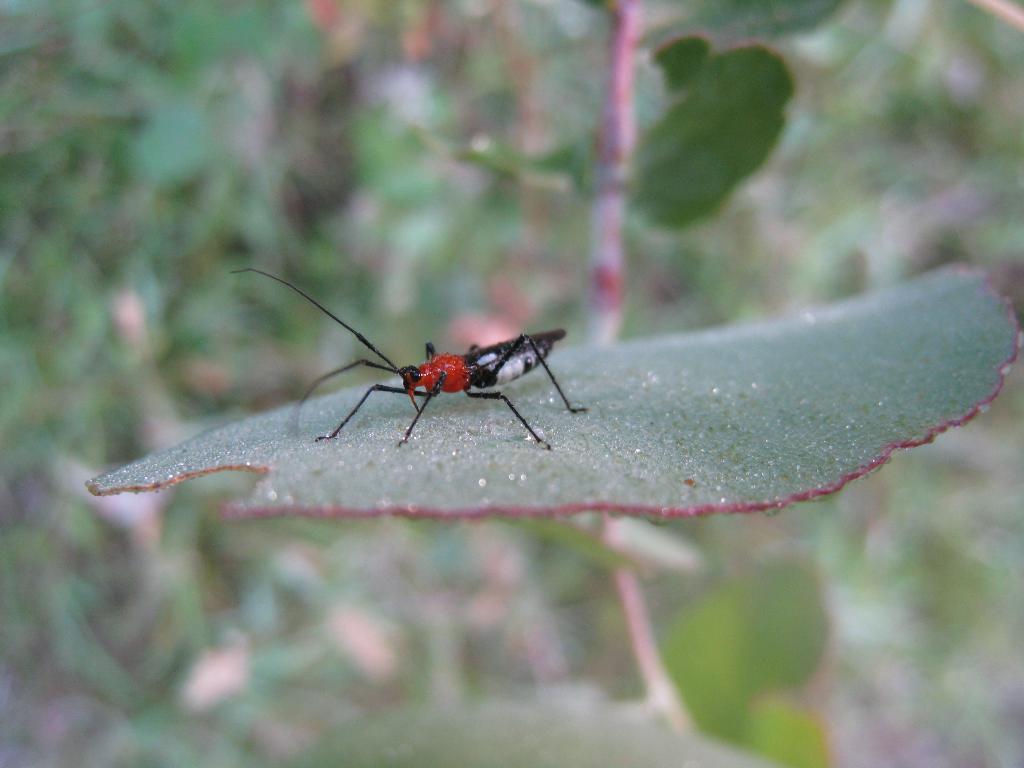Can you describe this image briefly? Here in this picture we can see an insect present on a leaf and beside that we can see plants in blurry manner. 